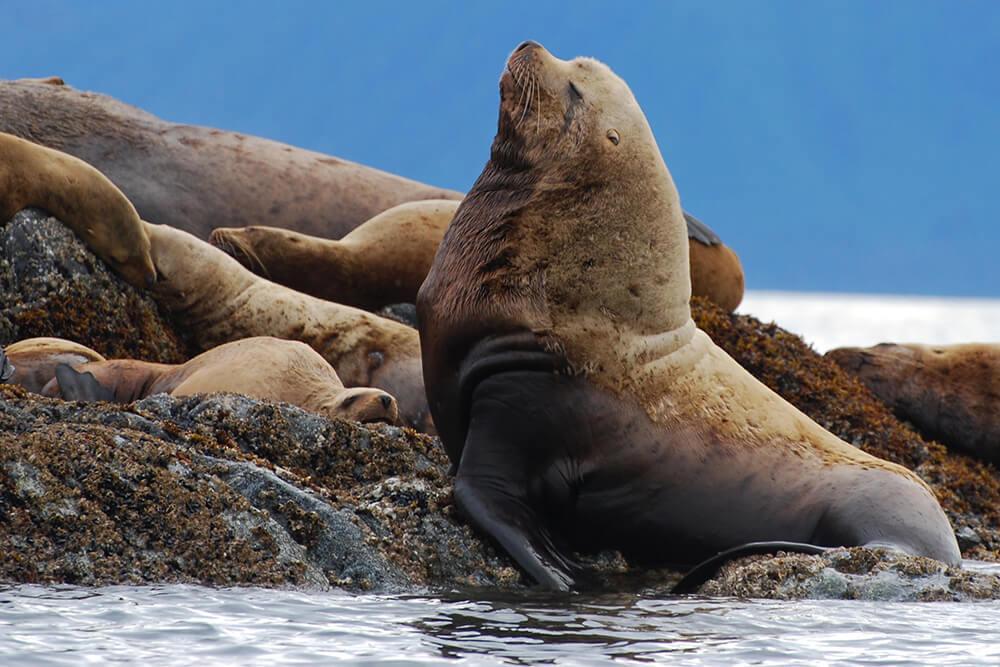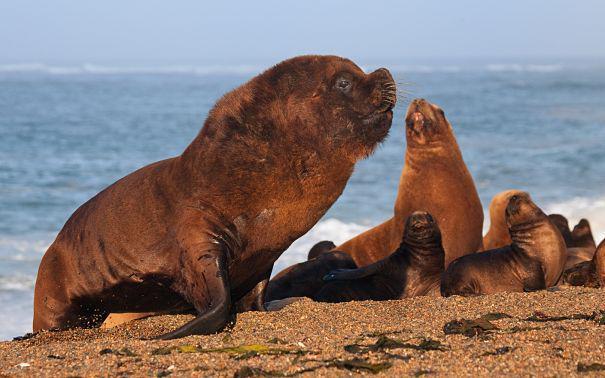The first image is the image on the left, the second image is the image on the right. Considering the images on both sides, is "There are several sea mammals in the picture on the right." valid? Answer yes or no. Yes. The first image is the image on the left, the second image is the image on the right. Given the left and right images, does the statement "One of the images contains a bird." hold true? Answer yes or no. No. 